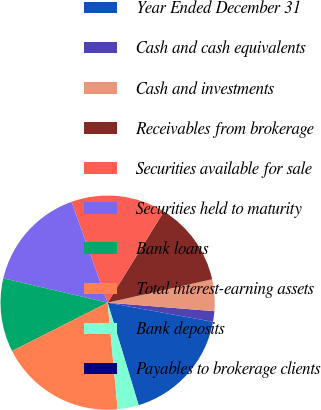Convert chart. <chart><loc_0><loc_0><loc_500><loc_500><pie_chart><fcel>Year Ended December 31<fcel>Cash and cash equivalents<fcel>Cash and investments<fcel>Receivables from brokerage<fcel>Securities available for sale<fcel>Securities held to maturity<fcel>Bank loans<fcel>Total interest-earning assets<fcel>Bank deposits<fcel>Payables to brokerage clients<nl><fcel>17.45%<fcel>1.6%<fcel>4.77%<fcel>12.7%<fcel>14.28%<fcel>15.87%<fcel>11.11%<fcel>19.04%<fcel>3.18%<fcel>0.01%<nl></chart> 